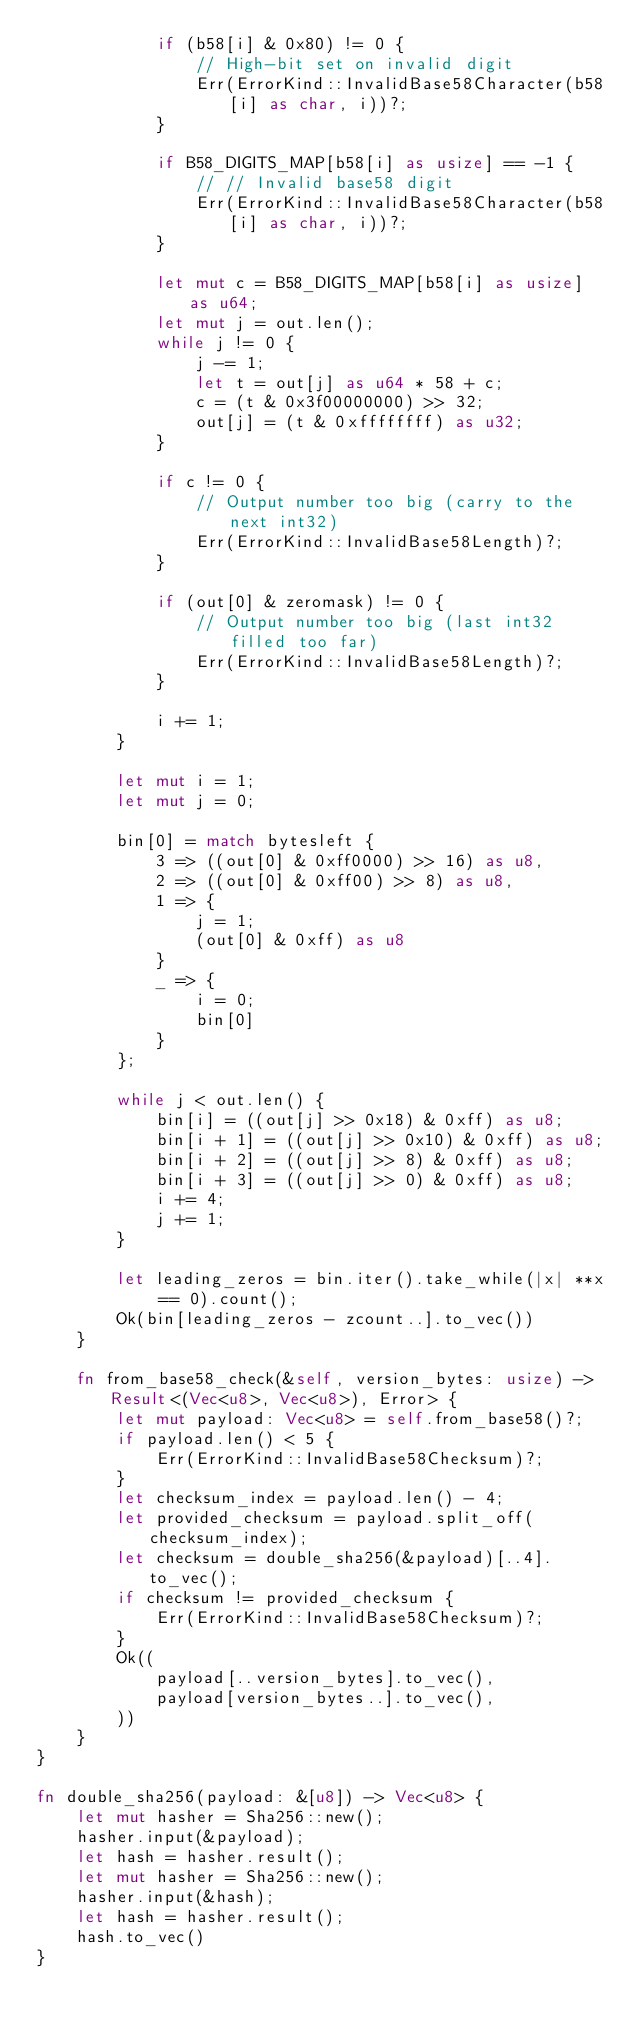<code> <loc_0><loc_0><loc_500><loc_500><_Rust_>            if (b58[i] & 0x80) != 0 {
                // High-bit set on invalid digit
                Err(ErrorKind::InvalidBase58Character(b58[i] as char, i))?;
            }

            if B58_DIGITS_MAP[b58[i] as usize] == -1 {
                // // Invalid base58 digit
                Err(ErrorKind::InvalidBase58Character(b58[i] as char, i))?;
            }

            let mut c = B58_DIGITS_MAP[b58[i] as usize] as u64;
            let mut j = out.len();
            while j != 0 {
                j -= 1;
                let t = out[j] as u64 * 58 + c;
                c = (t & 0x3f00000000) >> 32;
                out[j] = (t & 0xffffffff) as u32;
            }

            if c != 0 {
                // Output number too big (carry to the next int32)
                Err(ErrorKind::InvalidBase58Length)?;
            }

            if (out[0] & zeromask) != 0 {
                // Output number too big (last int32 filled too far)
                Err(ErrorKind::InvalidBase58Length)?;
            }

            i += 1;
        }

        let mut i = 1;
        let mut j = 0;

        bin[0] = match bytesleft {
            3 => ((out[0] & 0xff0000) >> 16) as u8,
            2 => ((out[0] & 0xff00) >> 8) as u8,
            1 => {
                j = 1;
                (out[0] & 0xff) as u8
            }
            _ => {
                i = 0;
                bin[0]
            }
        };

        while j < out.len() {
            bin[i] = ((out[j] >> 0x18) & 0xff) as u8;
            bin[i + 1] = ((out[j] >> 0x10) & 0xff) as u8;
            bin[i + 2] = ((out[j] >> 8) & 0xff) as u8;
            bin[i + 3] = ((out[j] >> 0) & 0xff) as u8;
            i += 4;
            j += 1;
        }

        let leading_zeros = bin.iter().take_while(|x| **x == 0).count();
        Ok(bin[leading_zeros - zcount..].to_vec())
    }

    fn from_base58_check(&self, version_bytes: usize) -> Result<(Vec<u8>, Vec<u8>), Error> {
        let mut payload: Vec<u8> = self.from_base58()?;
        if payload.len() < 5 {
            Err(ErrorKind::InvalidBase58Checksum)?;
        }
        let checksum_index = payload.len() - 4;
        let provided_checksum = payload.split_off(checksum_index);
        let checksum = double_sha256(&payload)[..4].to_vec();
        if checksum != provided_checksum {
            Err(ErrorKind::InvalidBase58Checksum)?;
        }
        Ok((
            payload[..version_bytes].to_vec(),
            payload[version_bytes..].to_vec(),
        ))
    }
}

fn double_sha256(payload: &[u8]) -> Vec<u8> {
    let mut hasher = Sha256::new();
    hasher.input(&payload);
    let hash = hasher.result();
    let mut hasher = Sha256::new();
    hasher.input(&hash);
    let hash = hasher.result();
    hash.to_vec()
}
</code> 